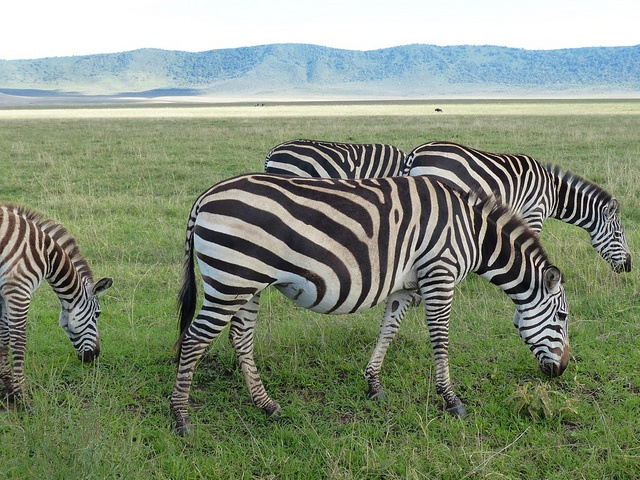Describe the objects in this image and their specific colors. I can see zebra in white, black, darkgray, gray, and tan tones, zebra in white, gray, black, and darkgray tones, zebra in white, black, gray, lightgray, and darkgray tones, and zebra in white, black, darkgray, gray, and lightgray tones in this image. 